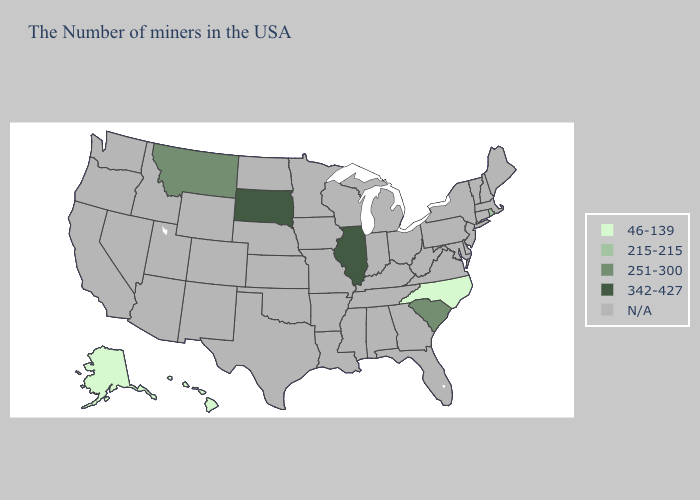Name the states that have a value in the range N/A?
Concise answer only. Maine, Massachusetts, New Hampshire, Vermont, Connecticut, New York, New Jersey, Delaware, Maryland, Pennsylvania, Virginia, West Virginia, Ohio, Florida, Georgia, Michigan, Kentucky, Indiana, Alabama, Tennessee, Wisconsin, Mississippi, Louisiana, Missouri, Arkansas, Minnesota, Iowa, Kansas, Nebraska, Oklahoma, Texas, North Dakota, Wyoming, Colorado, New Mexico, Utah, Arizona, Idaho, Nevada, California, Washington, Oregon. Name the states that have a value in the range 342-427?
Quick response, please. Illinois, South Dakota. What is the highest value in the USA?
Keep it brief. 342-427. What is the lowest value in states that border North Dakota?
Concise answer only. 251-300. What is the lowest value in the USA?
Quick response, please. 46-139. What is the value of Kansas?
Concise answer only. N/A. Does Montana have the lowest value in the West?
Concise answer only. No. What is the lowest value in the MidWest?
Be succinct. 342-427. Name the states that have a value in the range 251-300?
Quick response, please. South Carolina, Montana. Does the first symbol in the legend represent the smallest category?
Concise answer only. Yes. What is the value of West Virginia?
Write a very short answer. N/A. How many symbols are there in the legend?
Concise answer only. 5. Name the states that have a value in the range 215-215?
Answer briefly. Rhode Island. How many symbols are there in the legend?
Be succinct. 5. 